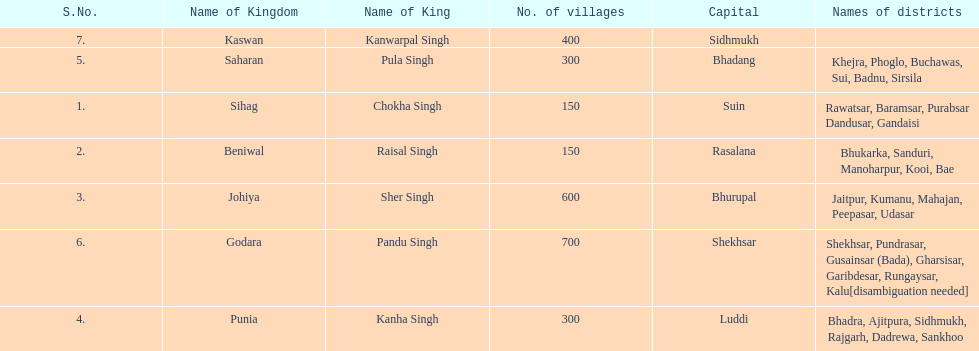What was the total number of districts within the state of godara? 7. 